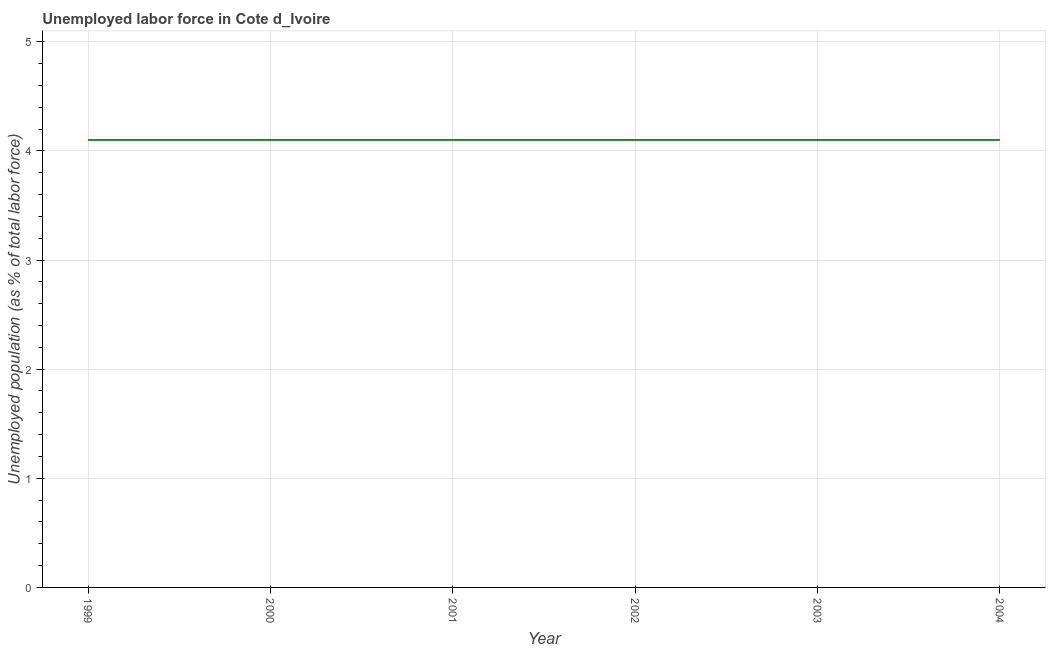What is the total unemployed population in 1999?
Provide a succinct answer. 4.1. Across all years, what is the maximum total unemployed population?
Give a very brief answer. 4.1. Across all years, what is the minimum total unemployed population?
Offer a terse response. 4.1. What is the sum of the total unemployed population?
Keep it short and to the point. 24.6. What is the difference between the total unemployed population in 2003 and 2004?
Offer a terse response. 0. What is the average total unemployed population per year?
Provide a succinct answer. 4.1. What is the median total unemployed population?
Your answer should be very brief. 4.1. In how many years, is the total unemployed population greater than 3.6 %?
Provide a succinct answer. 6. Is the sum of the total unemployed population in 2003 and 2004 greater than the maximum total unemployed population across all years?
Provide a succinct answer. Yes. Does the total unemployed population monotonically increase over the years?
Provide a short and direct response. No. Does the graph contain any zero values?
Provide a succinct answer. No. What is the title of the graph?
Your response must be concise. Unemployed labor force in Cote d_Ivoire. What is the label or title of the Y-axis?
Your answer should be very brief. Unemployed population (as % of total labor force). What is the Unemployed population (as % of total labor force) in 1999?
Keep it short and to the point. 4.1. What is the Unemployed population (as % of total labor force) of 2000?
Make the answer very short. 4.1. What is the Unemployed population (as % of total labor force) in 2001?
Keep it short and to the point. 4.1. What is the Unemployed population (as % of total labor force) of 2002?
Keep it short and to the point. 4.1. What is the Unemployed population (as % of total labor force) of 2003?
Provide a succinct answer. 4.1. What is the Unemployed population (as % of total labor force) in 2004?
Offer a very short reply. 4.1. What is the difference between the Unemployed population (as % of total labor force) in 1999 and 2002?
Your response must be concise. 0. What is the difference between the Unemployed population (as % of total labor force) in 1999 and 2003?
Offer a terse response. 0. What is the difference between the Unemployed population (as % of total labor force) in 1999 and 2004?
Your answer should be very brief. 0. What is the difference between the Unemployed population (as % of total labor force) in 2000 and 2001?
Ensure brevity in your answer.  0. What is the difference between the Unemployed population (as % of total labor force) in 2000 and 2002?
Provide a short and direct response. 0. What is the difference between the Unemployed population (as % of total labor force) in 2000 and 2003?
Your response must be concise. 0. What is the difference between the Unemployed population (as % of total labor force) in 2001 and 2002?
Your response must be concise. 0. What is the difference between the Unemployed population (as % of total labor force) in 2001 and 2003?
Ensure brevity in your answer.  0. What is the difference between the Unemployed population (as % of total labor force) in 2001 and 2004?
Keep it short and to the point. 0. What is the difference between the Unemployed population (as % of total labor force) in 2002 and 2003?
Ensure brevity in your answer.  0. What is the ratio of the Unemployed population (as % of total labor force) in 1999 to that in 2000?
Provide a short and direct response. 1. What is the ratio of the Unemployed population (as % of total labor force) in 1999 to that in 2001?
Offer a terse response. 1. What is the ratio of the Unemployed population (as % of total labor force) in 2000 to that in 2001?
Your answer should be compact. 1. What is the ratio of the Unemployed population (as % of total labor force) in 2000 to that in 2004?
Your answer should be compact. 1. What is the ratio of the Unemployed population (as % of total labor force) in 2001 to that in 2004?
Offer a terse response. 1. What is the ratio of the Unemployed population (as % of total labor force) in 2002 to that in 2004?
Provide a succinct answer. 1. 